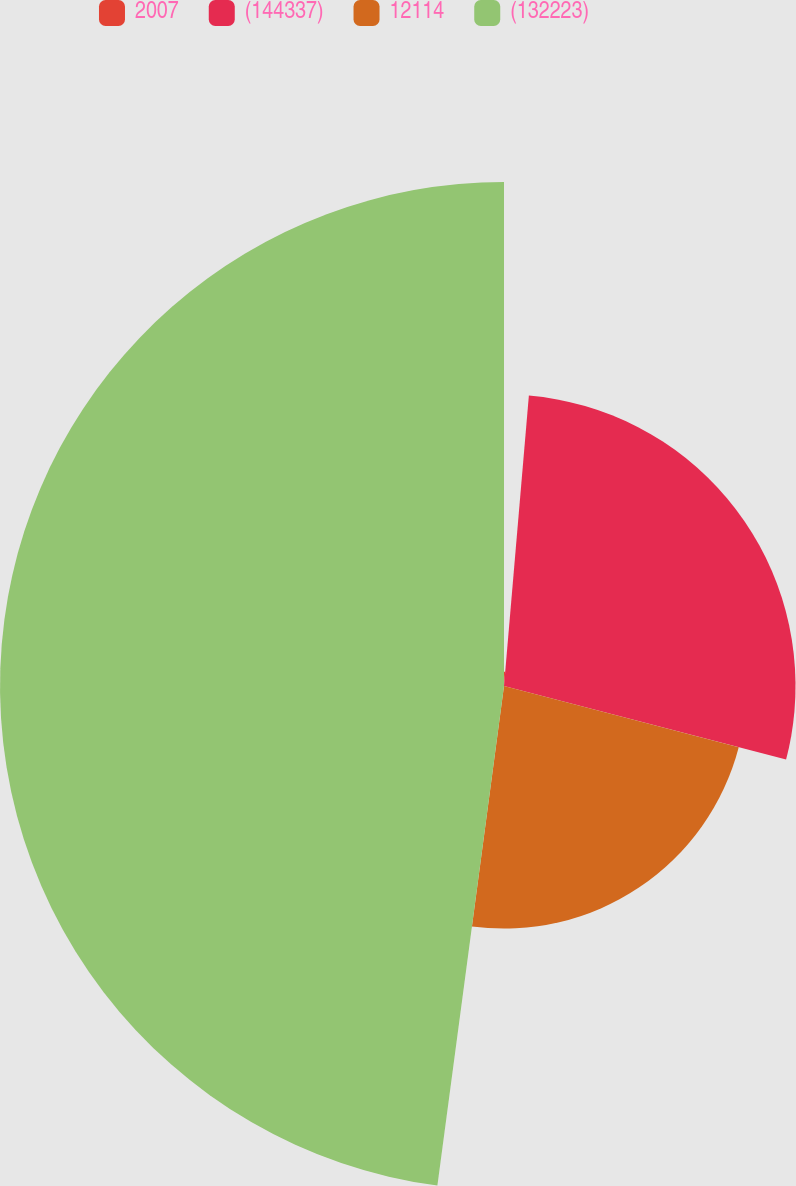<chart> <loc_0><loc_0><loc_500><loc_500><pie_chart><fcel>2007<fcel>(144337)<fcel>12114<fcel>(132223)<nl><fcel>1.36%<fcel>27.7%<fcel>23.05%<fcel>47.89%<nl></chart> 